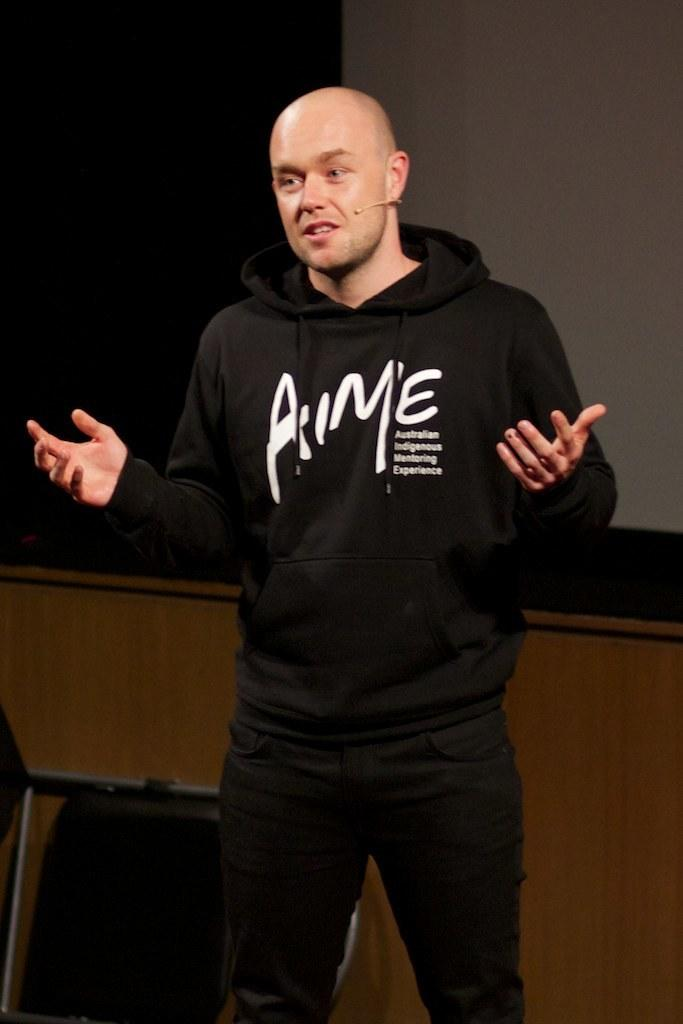Who is present in the image? There is a man in the picture. What is the man wearing? The man is wearing a black dress. What is the man doing in the image? The man is speaking. What can be seen behind the man? There is a wall behind the man. What is beside the wall? There is a black surface beside the wall. What type of grass can be seen growing on the black surface? There is no grass present in the image; the black surface is beside the wall. 